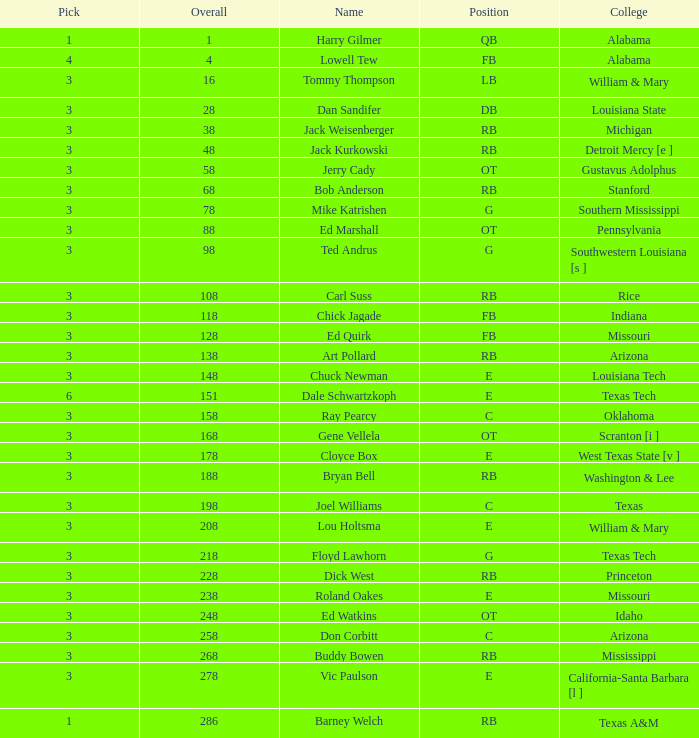Which Overall has a Name of bob anderson, and a Round smaller than 9? None. 